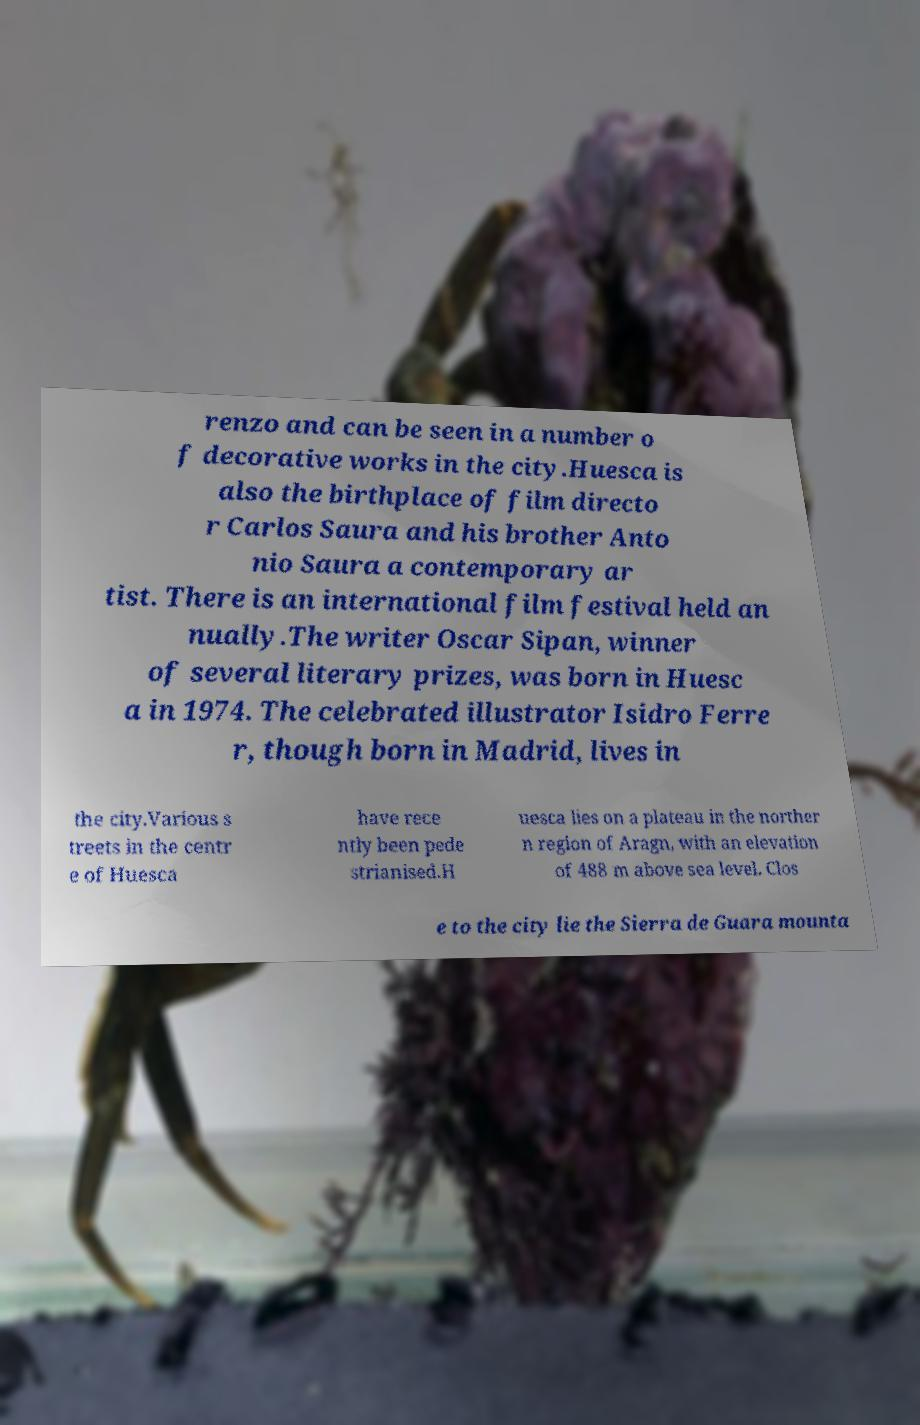I need the written content from this picture converted into text. Can you do that? renzo and can be seen in a number o f decorative works in the city.Huesca is also the birthplace of film directo r Carlos Saura and his brother Anto nio Saura a contemporary ar tist. There is an international film festival held an nually.The writer Oscar Sipan, winner of several literary prizes, was born in Huesc a in 1974. The celebrated illustrator Isidro Ferre r, though born in Madrid, lives in the city.Various s treets in the centr e of Huesca have rece ntly been pede strianised.H uesca lies on a plateau in the norther n region of Aragn, with an elevation of 488 m above sea level. Clos e to the city lie the Sierra de Guara mounta 